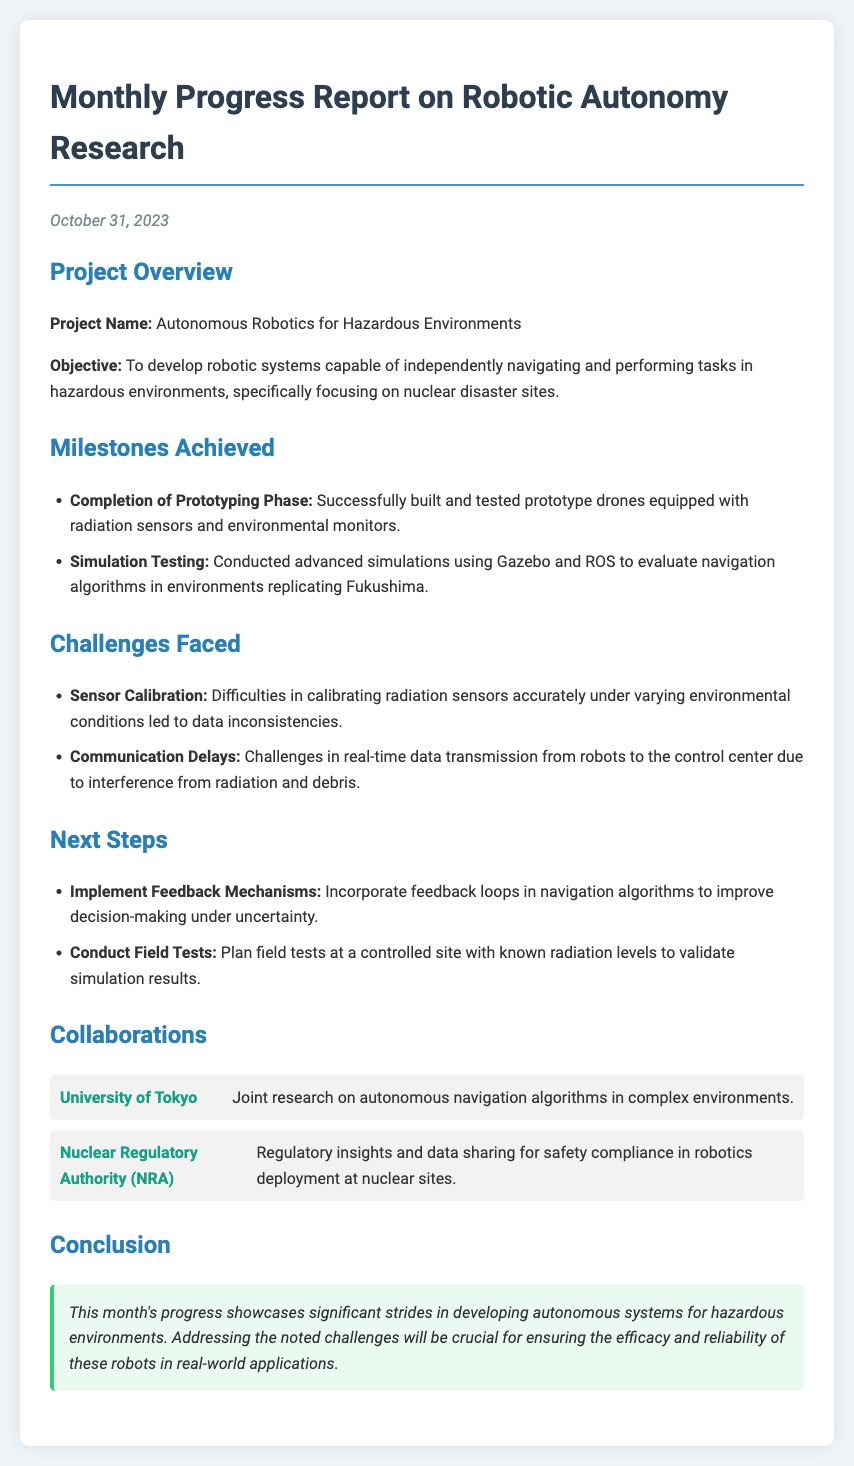What is the project name? The project name is stated in the project overview section of the document.
Answer: Autonomous Robotics for Hazardous Environments When was the report issued? The date of the report is mentioned at the beginning of the document.
Answer: October 31, 2023 What milestone was achieved related to prototyping? The section on milestones achieved details completed tasks; this particular milestone is noted explicitly.
Answer: Completion of Prototyping Phase What was one challenge faced during the project? The challenges faced section lists specific issues encountered while working on the project.
Answer: Sensor Calibration What are the next steps planned for the project? The next steps section outlines future actions to address ongoing work and improvements.
Answer: Implement Feedback Mechanisms Which university is listed as a collaborator? The collaborations section names partnering organizations working on the project.
Answer: University of Tokyo What technology was used in simulation testing? The document mentions specific technologies related to the testing conducted during the project.
Answer: Gazebo and ROS What is highlighted as crucial for project efficacy? The conclusion summarizes key points from the report, including important factors for success.
Answer: Addressing the noted challenges 